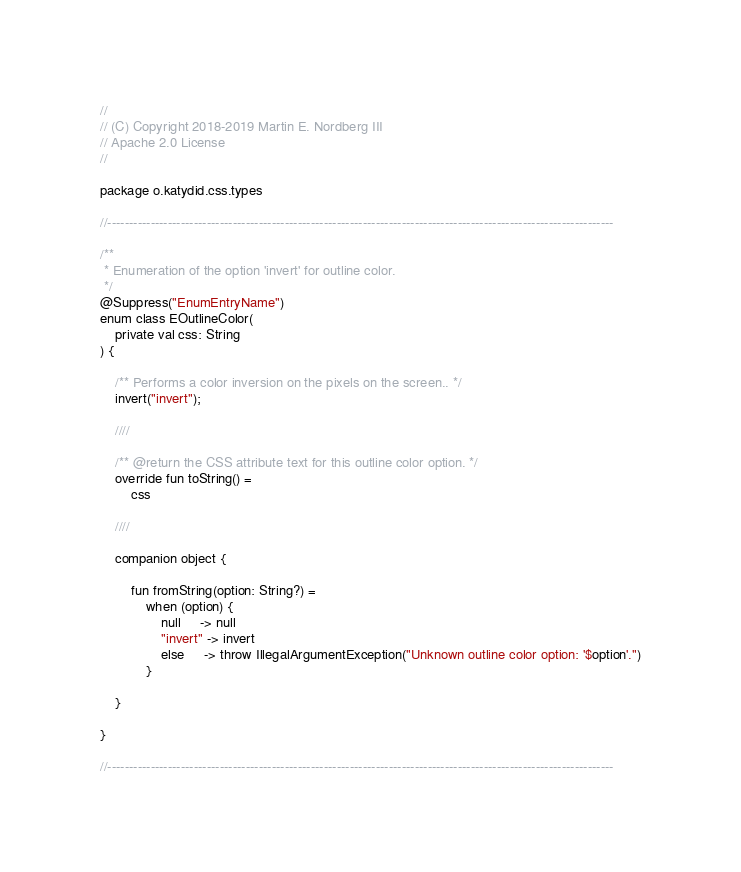<code> <loc_0><loc_0><loc_500><loc_500><_Kotlin_>//
// (C) Copyright 2018-2019 Martin E. Nordberg III
// Apache 2.0 License
//

package o.katydid.css.types

//---------------------------------------------------------------------------------------------------------------------

/**
 * Enumeration of the option 'invert' for outline color.
 */
@Suppress("EnumEntryName")
enum class EOutlineColor(
    private val css: String
) {

    /** Performs a color inversion on the pixels on the screen.. */
    invert("invert");

    ////

    /** @return the CSS attribute text for this outline color option. */
    override fun toString() =
        css

    ////

    companion object {

        fun fromString(option: String?) =
            when (option) {
                null     -> null
                "invert" -> invert
                else     -> throw IllegalArgumentException("Unknown outline color option: '$option'.")
            }

    }

}

//---------------------------------------------------------------------------------------------------------------------

</code> 